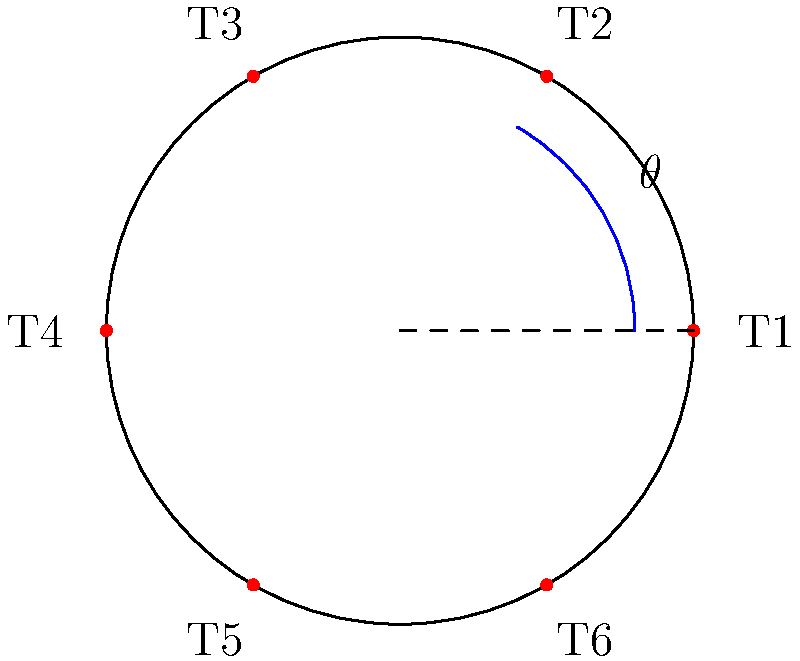Count Björn von Finnmark is planning to construct a circular castle with a radius of 120 meters. To optimize security, he wants to place guard towers at equal intervals around the perimeter. If each tower needs to cover an arc of 60 degrees, how many towers should be built, and what will be the distance between adjacent towers along the circumference? Let's approach this step-by-step:

1) First, we need to determine how many 60-degree arcs fit around a full circle:
   $$\frac{360°}{60°} = 6$$
   This means we need 6 towers.

2) To find the distance between towers, we need to calculate the circumference of the castle:
   $$C = 2\pi r = 2\pi \cdot 120 = 240\pi \approx 753.98 \text{ meters}$$

3) Since the towers are equally spaced, we can divide the circumference by the number of towers:
   $$\text{Distance between towers} = \frac{C}{6} = \frac{240\pi}{6} = 40\pi \approx 125.66 \text{ meters}$$

4) We can verify this using the arc length formula:
   $$s = r\theta$$
   where $s$ is the arc length, $r$ is the radius, and $\theta$ is the central angle in radians.
   
   $$\theta = 60° = \frac{\pi}{3} \text{ radians}$$
   $$s = 120 \cdot \frac{\pi}{3} = 40\pi \approx 125.66 \text{ meters}$$

This confirms our calculation.
Answer: 6 towers, $40\pi$ meters apart (approximately 125.66 meters) 